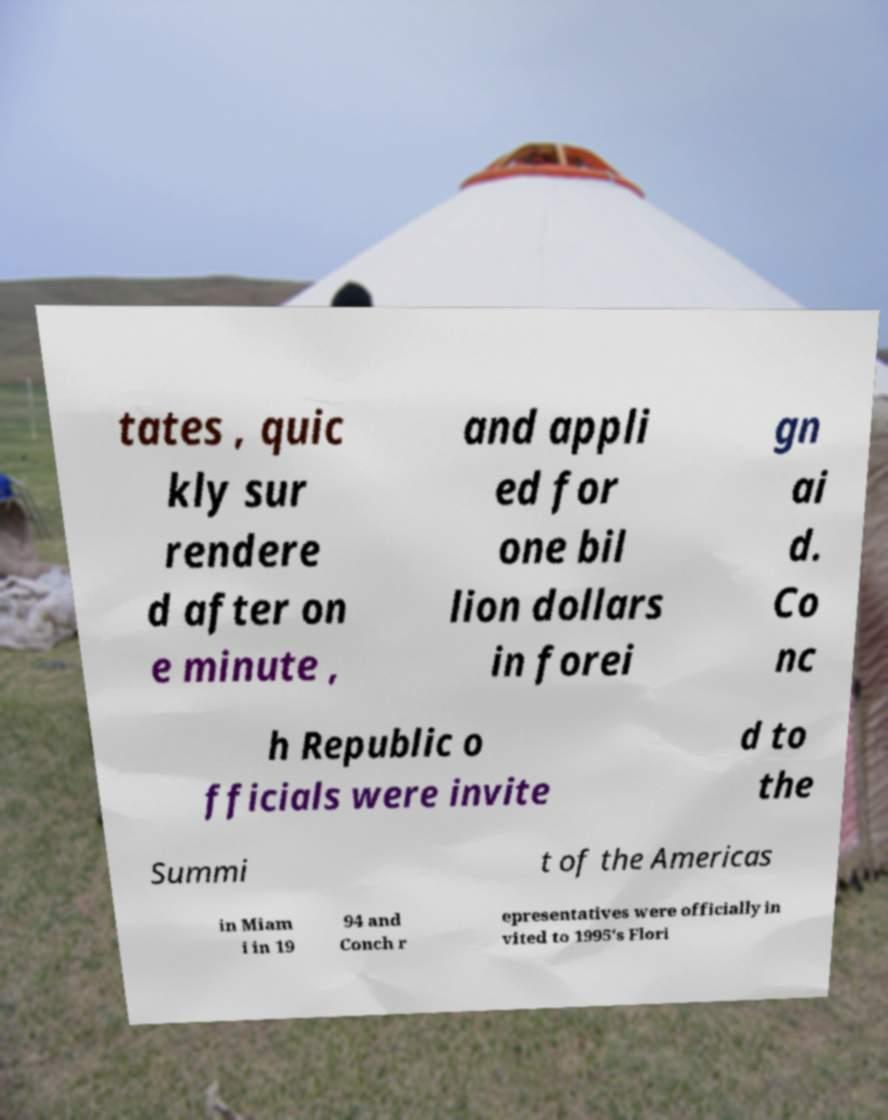Can you accurately transcribe the text from the provided image for me? tates , quic kly sur rendere d after on e minute , and appli ed for one bil lion dollars in forei gn ai d. Co nc h Republic o fficials were invite d to the Summi t of the Americas in Miam i in 19 94 and Conch r epresentatives were officially in vited to 1995's Flori 